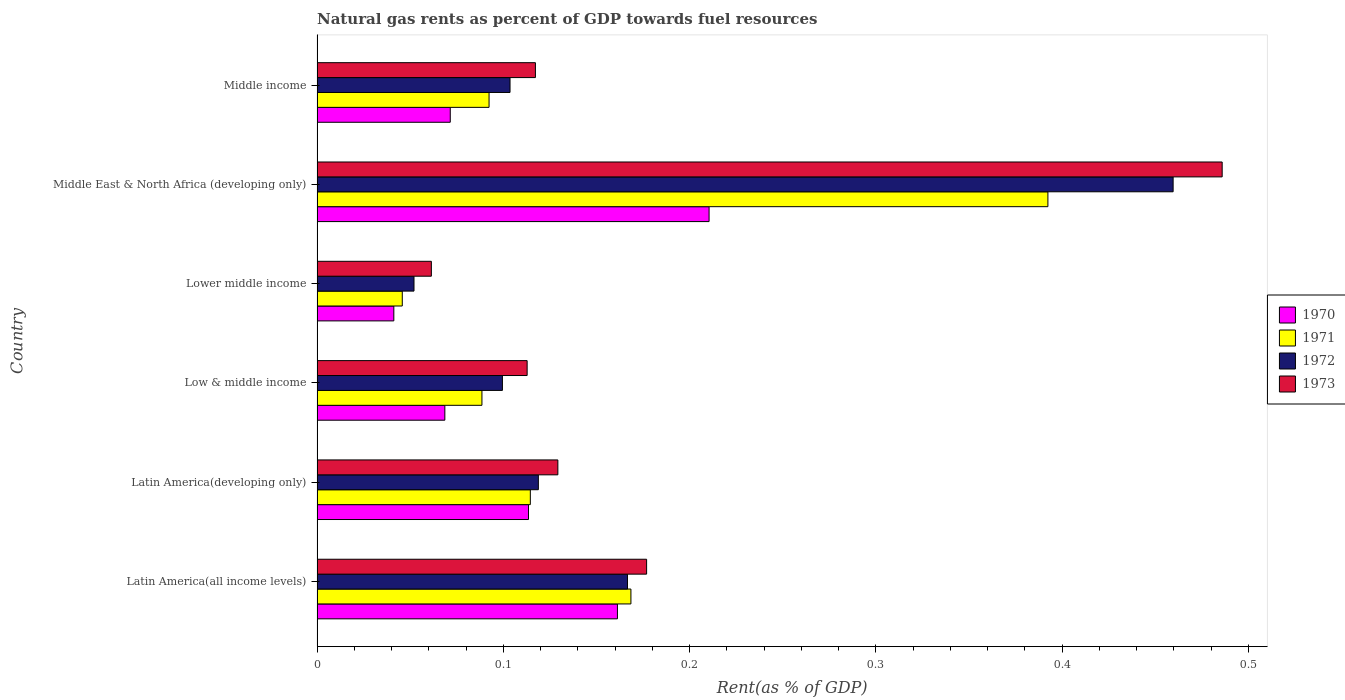Are the number of bars per tick equal to the number of legend labels?
Your answer should be very brief. Yes. How many bars are there on the 2nd tick from the bottom?
Give a very brief answer. 4. What is the label of the 2nd group of bars from the top?
Offer a terse response. Middle East & North Africa (developing only). In how many cases, is the number of bars for a given country not equal to the number of legend labels?
Offer a terse response. 0. What is the matural gas rent in 1972 in Middle East & North Africa (developing only)?
Make the answer very short. 0.46. Across all countries, what is the maximum matural gas rent in 1971?
Offer a terse response. 0.39. Across all countries, what is the minimum matural gas rent in 1973?
Ensure brevity in your answer.  0.06. In which country was the matural gas rent in 1973 maximum?
Provide a short and direct response. Middle East & North Africa (developing only). In which country was the matural gas rent in 1972 minimum?
Your answer should be very brief. Lower middle income. What is the total matural gas rent in 1971 in the graph?
Make the answer very short. 0.9. What is the difference between the matural gas rent in 1972 in Latin America(all income levels) and that in Middle East & North Africa (developing only)?
Make the answer very short. -0.29. What is the difference between the matural gas rent in 1971 in Latin America(developing only) and the matural gas rent in 1970 in Lower middle income?
Your response must be concise. 0.07. What is the average matural gas rent in 1970 per country?
Offer a terse response. 0.11. What is the difference between the matural gas rent in 1972 and matural gas rent in 1970 in Middle East & North Africa (developing only)?
Ensure brevity in your answer.  0.25. What is the ratio of the matural gas rent in 1970 in Latin America(all income levels) to that in Lower middle income?
Ensure brevity in your answer.  3.91. Is the matural gas rent in 1971 in Latin America(developing only) less than that in Middle income?
Provide a succinct answer. No. What is the difference between the highest and the second highest matural gas rent in 1972?
Keep it short and to the point. 0.29. What is the difference between the highest and the lowest matural gas rent in 1970?
Offer a very short reply. 0.17. In how many countries, is the matural gas rent in 1970 greater than the average matural gas rent in 1970 taken over all countries?
Your response must be concise. 3. Is it the case that in every country, the sum of the matural gas rent in 1972 and matural gas rent in 1970 is greater than the sum of matural gas rent in 1971 and matural gas rent in 1973?
Give a very brief answer. No. What does the 4th bar from the top in Low & middle income represents?
Offer a terse response. 1970. What does the 3rd bar from the bottom in Lower middle income represents?
Offer a terse response. 1972. How many bars are there?
Your response must be concise. 24. Are all the bars in the graph horizontal?
Offer a very short reply. Yes. How many countries are there in the graph?
Make the answer very short. 6. How are the legend labels stacked?
Ensure brevity in your answer.  Vertical. What is the title of the graph?
Provide a short and direct response. Natural gas rents as percent of GDP towards fuel resources. Does "1989" appear as one of the legend labels in the graph?
Give a very brief answer. No. What is the label or title of the X-axis?
Provide a short and direct response. Rent(as % of GDP). What is the Rent(as % of GDP) of 1970 in Latin America(all income levels)?
Your answer should be very brief. 0.16. What is the Rent(as % of GDP) of 1971 in Latin America(all income levels)?
Offer a terse response. 0.17. What is the Rent(as % of GDP) of 1972 in Latin America(all income levels)?
Make the answer very short. 0.17. What is the Rent(as % of GDP) in 1973 in Latin America(all income levels)?
Your answer should be compact. 0.18. What is the Rent(as % of GDP) of 1970 in Latin America(developing only)?
Offer a terse response. 0.11. What is the Rent(as % of GDP) in 1971 in Latin America(developing only)?
Make the answer very short. 0.11. What is the Rent(as % of GDP) of 1972 in Latin America(developing only)?
Keep it short and to the point. 0.12. What is the Rent(as % of GDP) of 1973 in Latin America(developing only)?
Provide a succinct answer. 0.13. What is the Rent(as % of GDP) in 1970 in Low & middle income?
Your answer should be very brief. 0.07. What is the Rent(as % of GDP) in 1971 in Low & middle income?
Provide a short and direct response. 0.09. What is the Rent(as % of GDP) in 1972 in Low & middle income?
Your answer should be very brief. 0.1. What is the Rent(as % of GDP) of 1973 in Low & middle income?
Ensure brevity in your answer.  0.11. What is the Rent(as % of GDP) in 1970 in Lower middle income?
Ensure brevity in your answer.  0.04. What is the Rent(as % of GDP) of 1971 in Lower middle income?
Offer a very short reply. 0.05. What is the Rent(as % of GDP) in 1972 in Lower middle income?
Provide a succinct answer. 0.05. What is the Rent(as % of GDP) of 1973 in Lower middle income?
Give a very brief answer. 0.06. What is the Rent(as % of GDP) in 1970 in Middle East & North Africa (developing only)?
Make the answer very short. 0.21. What is the Rent(as % of GDP) in 1971 in Middle East & North Africa (developing only)?
Offer a terse response. 0.39. What is the Rent(as % of GDP) of 1972 in Middle East & North Africa (developing only)?
Your response must be concise. 0.46. What is the Rent(as % of GDP) of 1973 in Middle East & North Africa (developing only)?
Keep it short and to the point. 0.49. What is the Rent(as % of GDP) in 1970 in Middle income?
Give a very brief answer. 0.07. What is the Rent(as % of GDP) in 1971 in Middle income?
Your answer should be compact. 0.09. What is the Rent(as % of GDP) in 1972 in Middle income?
Your answer should be compact. 0.1. What is the Rent(as % of GDP) of 1973 in Middle income?
Ensure brevity in your answer.  0.12. Across all countries, what is the maximum Rent(as % of GDP) in 1970?
Make the answer very short. 0.21. Across all countries, what is the maximum Rent(as % of GDP) of 1971?
Your answer should be very brief. 0.39. Across all countries, what is the maximum Rent(as % of GDP) in 1972?
Provide a succinct answer. 0.46. Across all countries, what is the maximum Rent(as % of GDP) of 1973?
Your answer should be very brief. 0.49. Across all countries, what is the minimum Rent(as % of GDP) of 1970?
Offer a very short reply. 0.04. Across all countries, what is the minimum Rent(as % of GDP) of 1971?
Keep it short and to the point. 0.05. Across all countries, what is the minimum Rent(as % of GDP) of 1972?
Provide a succinct answer. 0.05. Across all countries, what is the minimum Rent(as % of GDP) of 1973?
Your answer should be compact. 0.06. What is the total Rent(as % of GDP) of 1970 in the graph?
Your answer should be very brief. 0.67. What is the total Rent(as % of GDP) of 1971 in the graph?
Your answer should be very brief. 0.9. What is the total Rent(as % of GDP) in 1972 in the graph?
Your answer should be compact. 1. What is the total Rent(as % of GDP) in 1973 in the graph?
Make the answer very short. 1.08. What is the difference between the Rent(as % of GDP) of 1970 in Latin America(all income levels) and that in Latin America(developing only)?
Offer a very short reply. 0.05. What is the difference between the Rent(as % of GDP) of 1971 in Latin America(all income levels) and that in Latin America(developing only)?
Provide a short and direct response. 0.05. What is the difference between the Rent(as % of GDP) in 1972 in Latin America(all income levels) and that in Latin America(developing only)?
Offer a terse response. 0.05. What is the difference between the Rent(as % of GDP) in 1973 in Latin America(all income levels) and that in Latin America(developing only)?
Your response must be concise. 0.05. What is the difference between the Rent(as % of GDP) in 1970 in Latin America(all income levels) and that in Low & middle income?
Offer a terse response. 0.09. What is the difference between the Rent(as % of GDP) of 1972 in Latin America(all income levels) and that in Low & middle income?
Offer a very short reply. 0.07. What is the difference between the Rent(as % of GDP) in 1973 in Latin America(all income levels) and that in Low & middle income?
Give a very brief answer. 0.06. What is the difference between the Rent(as % of GDP) of 1970 in Latin America(all income levels) and that in Lower middle income?
Your answer should be compact. 0.12. What is the difference between the Rent(as % of GDP) in 1971 in Latin America(all income levels) and that in Lower middle income?
Give a very brief answer. 0.12. What is the difference between the Rent(as % of GDP) of 1972 in Latin America(all income levels) and that in Lower middle income?
Offer a very short reply. 0.11. What is the difference between the Rent(as % of GDP) in 1973 in Latin America(all income levels) and that in Lower middle income?
Give a very brief answer. 0.12. What is the difference between the Rent(as % of GDP) in 1970 in Latin America(all income levels) and that in Middle East & North Africa (developing only)?
Ensure brevity in your answer.  -0.05. What is the difference between the Rent(as % of GDP) in 1971 in Latin America(all income levels) and that in Middle East & North Africa (developing only)?
Give a very brief answer. -0.22. What is the difference between the Rent(as % of GDP) in 1972 in Latin America(all income levels) and that in Middle East & North Africa (developing only)?
Your answer should be compact. -0.29. What is the difference between the Rent(as % of GDP) of 1973 in Latin America(all income levels) and that in Middle East & North Africa (developing only)?
Make the answer very short. -0.31. What is the difference between the Rent(as % of GDP) of 1970 in Latin America(all income levels) and that in Middle income?
Your answer should be compact. 0.09. What is the difference between the Rent(as % of GDP) in 1971 in Latin America(all income levels) and that in Middle income?
Your answer should be very brief. 0.08. What is the difference between the Rent(as % of GDP) in 1972 in Latin America(all income levels) and that in Middle income?
Your answer should be very brief. 0.06. What is the difference between the Rent(as % of GDP) of 1973 in Latin America(all income levels) and that in Middle income?
Your answer should be compact. 0.06. What is the difference between the Rent(as % of GDP) of 1970 in Latin America(developing only) and that in Low & middle income?
Give a very brief answer. 0.04. What is the difference between the Rent(as % of GDP) of 1971 in Latin America(developing only) and that in Low & middle income?
Offer a terse response. 0.03. What is the difference between the Rent(as % of GDP) of 1972 in Latin America(developing only) and that in Low & middle income?
Provide a succinct answer. 0.02. What is the difference between the Rent(as % of GDP) in 1973 in Latin America(developing only) and that in Low & middle income?
Make the answer very short. 0.02. What is the difference between the Rent(as % of GDP) in 1970 in Latin America(developing only) and that in Lower middle income?
Provide a short and direct response. 0.07. What is the difference between the Rent(as % of GDP) in 1971 in Latin America(developing only) and that in Lower middle income?
Provide a succinct answer. 0.07. What is the difference between the Rent(as % of GDP) in 1972 in Latin America(developing only) and that in Lower middle income?
Provide a short and direct response. 0.07. What is the difference between the Rent(as % of GDP) in 1973 in Latin America(developing only) and that in Lower middle income?
Your answer should be compact. 0.07. What is the difference between the Rent(as % of GDP) of 1970 in Latin America(developing only) and that in Middle East & North Africa (developing only)?
Keep it short and to the point. -0.1. What is the difference between the Rent(as % of GDP) in 1971 in Latin America(developing only) and that in Middle East & North Africa (developing only)?
Your answer should be very brief. -0.28. What is the difference between the Rent(as % of GDP) of 1972 in Latin America(developing only) and that in Middle East & North Africa (developing only)?
Ensure brevity in your answer.  -0.34. What is the difference between the Rent(as % of GDP) in 1973 in Latin America(developing only) and that in Middle East & North Africa (developing only)?
Your answer should be compact. -0.36. What is the difference between the Rent(as % of GDP) in 1970 in Latin America(developing only) and that in Middle income?
Keep it short and to the point. 0.04. What is the difference between the Rent(as % of GDP) in 1971 in Latin America(developing only) and that in Middle income?
Your response must be concise. 0.02. What is the difference between the Rent(as % of GDP) of 1972 in Latin America(developing only) and that in Middle income?
Make the answer very short. 0.02. What is the difference between the Rent(as % of GDP) of 1973 in Latin America(developing only) and that in Middle income?
Provide a short and direct response. 0.01. What is the difference between the Rent(as % of GDP) of 1970 in Low & middle income and that in Lower middle income?
Make the answer very short. 0.03. What is the difference between the Rent(as % of GDP) of 1971 in Low & middle income and that in Lower middle income?
Provide a short and direct response. 0.04. What is the difference between the Rent(as % of GDP) of 1972 in Low & middle income and that in Lower middle income?
Your answer should be compact. 0.05. What is the difference between the Rent(as % of GDP) of 1973 in Low & middle income and that in Lower middle income?
Provide a short and direct response. 0.05. What is the difference between the Rent(as % of GDP) of 1970 in Low & middle income and that in Middle East & North Africa (developing only)?
Provide a succinct answer. -0.14. What is the difference between the Rent(as % of GDP) of 1971 in Low & middle income and that in Middle East & North Africa (developing only)?
Your answer should be very brief. -0.3. What is the difference between the Rent(as % of GDP) of 1972 in Low & middle income and that in Middle East & North Africa (developing only)?
Your answer should be compact. -0.36. What is the difference between the Rent(as % of GDP) in 1973 in Low & middle income and that in Middle East & North Africa (developing only)?
Your answer should be very brief. -0.37. What is the difference between the Rent(as % of GDP) of 1970 in Low & middle income and that in Middle income?
Provide a short and direct response. -0. What is the difference between the Rent(as % of GDP) in 1971 in Low & middle income and that in Middle income?
Your answer should be very brief. -0. What is the difference between the Rent(as % of GDP) of 1972 in Low & middle income and that in Middle income?
Your answer should be compact. -0. What is the difference between the Rent(as % of GDP) in 1973 in Low & middle income and that in Middle income?
Make the answer very short. -0. What is the difference between the Rent(as % of GDP) of 1970 in Lower middle income and that in Middle East & North Africa (developing only)?
Provide a short and direct response. -0.17. What is the difference between the Rent(as % of GDP) of 1971 in Lower middle income and that in Middle East & North Africa (developing only)?
Keep it short and to the point. -0.35. What is the difference between the Rent(as % of GDP) in 1972 in Lower middle income and that in Middle East & North Africa (developing only)?
Provide a short and direct response. -0.41. What is the difference between the Rent(as % of GDP) of 1973 in Lower middle income and that in Middle East & North Africa (developing only)?
Give a very brief answer. -0.42. What is the difference between the Rent(as % of GDP) of 1970 in Lower middle income and that in Middle income?
Make the answer very short. -0.03. What is the difference between the Rent(as % of GDP) of 1971 in Lower middle income and that in Middle income?
Your answer should be very brief. -0.05. What is the difference between the Rent(as % of GDP) in 1972 in Lower middle income and that in Middle income?
Your answer should be very brief. -0.05. What is the difference between the Rent(as % of GDP) of 1973 in Lower middle income and that in Middle income?
Offer a terse response. -0.06. What is the difference between the Rent(as % of GDP) in 1970 in Middle East & North Africa (developing only) and that in Middle income?
Provide a short and direct response. 0.14. What is the difference between the Rent(as % of GDP) in 1972 in Middle East & North Africa (developing only) and that in Middle income?
Provide a short and direct response. 0.36. What is the difference between the Rent(as % of GDP) in 1973 in Middle East & North Africa (developing only) and that in Middle income?
Make the answer very short. 0.37. What is the difference between the Rent(as % of GDP) in 1970 in Latin America(all income levels) and the Rent(as % of GDP) in 1971 in Latin America(developing only)?
Provide a succinct answer. 0.05. What is the difference between the Rent(as % of GDP) in 1970 in Latin America(all income levels) and the Rent(as % of GDP) in 1972 in Latin America(developing only)?
Your response must be concise. 0.04. What is the difference between the Rent(as % of GDP) in 1970 in Latin America(all income levels) and the Rent(as % of GDP) in 1973 in Latin America(developing only)?
Offer a terse response. 0.03. What is the difference between the Rent(as % of GDP) in 1971 in Latin America(all income levels) and the Rent(as % of GDP) in 1972 in Latin America(developing only)?
Provide a short and direct response. 0.05. What is the difference between the Rent(as % of GDP) in 1971 in Latin America(all income levels) and the Rent(as % of GDP) in 1973 in Latin America(developing only)?
Offer a very short reply. 0.04. What is the difference between the Rent(as % of GDP) of 1972 in Latin America(all income levels) and the Rent(as % of GDP) of 1973 in Latin America(developing only)?
Provide a short and direct response. 0.04. What is the difference between the Rent(as % of GDP) of 1970 in Latin America(all income levels) and the Rent(as % of GDP) of 1971 in Low & middle income?
Provide a succinct answer. 0.07. What is the difference between the Rent(as % of GDP) of 1970 in Latin America(all income levels) and the Rent(as % of GDP) of 1972 in Low & middle income?
Keep it short and to the point. 0.06. What is the difference between the Rent(as % of GDP) of 1970 in Latin America(all income levels) and the Rent(as % of GDP) of 1973 in Low & middle income?
Your answer should be very brief. 0.05. What is the difference between the Rent(as % of GDP) of 1971 in Latin America(all income levels) and the Rent(as % of GDP) of 1972 in Low & middle income?
Provide a succinct answer. 0.07. What is the difference between the Rent(as % of GDP) in 1971 in Latin America(all income levels) and the Rent(as % of GDP) in 1973 in Low & middle income?
Your answer should be compact. 0.06. What is the difference between the Rent(as % of GDP) in 1972 in Latin America(all income levels) and the Rent(as % of GDP) in 1973 in Low & middle income?
Your answer should be very brief. 0.05. What is the difference between the Rent(as % of GDP) in 1970 in Latin America(all income levels) and the Rent(as % of GDP) in 1971 in Lower middle income?
Your answer should be compact. 0.12. What is the difference between the Rent(as % of GDP) in 1970 in Latin America(all income levels) and the Rent(as % of GDP) in 1972 in Lower middle income?
Your response must be concise. 0.11. What is the difference between the Rent(as % of GDP) in 1970 in Latin America(all income levels) and the Rent(as % of GDP) in 1973 in Lower middle income?
Your response must be concise. 0.1. What is the difference between the Rent(as % of GDP) in 1971 in Latin America(all income levels) and the Rent(as % of GDP) in 1972 in Lower middle income?
Make the answer very short. 0.12. What is the difference between the Rent(as % of GDP) in 1971 in Latin America(all income levels) and the Rent(as % of GDP) in 1973 in Lower middle income?
Provide a succinct answer. 0.11. What is the difference between the Rent(as % of GDP) in 1972 in Latin America(all income levels) and the Rent(as % of GDP) in 1973 in Lower middle income?
Offer a terse response. 0.11. What is the difference between the Rent(as % of GDP) in 1970 in Latin America(all income levels) and the Rent(as % of GDP) in 1971 in Middle East & North Africa (developing only)?
Your answer should be compact. -0.23. What is the difference between the Rent(as % of GDP) of 1970 in Latin America(all income levels) and the Rent(as % of GDP) of 1972 in Middle East & North Africa (developing only)?
Your answer should be compact. -0.3. What is the difference between the Rent(as % of GDP) in 1970 in Latin America(all income levels) and the Rent(as % of GDP) in 1973 in Middle East & North Africa (developing only)?
Your answer should be very brief. -0.32. What is the difference between the Rent(as % of GDP) of 1971 in Latin America(all income levels) and the Rent(as % of GDP) of 1972 in Middle East & North Africa (developing only)?
Ensure brevity in your answer.  -0.29. What is the difference between the Rent(as % of GDP) in 1971 in Latin America(all income levels) and the Rent(as % of GDP) in 1973 in Middle East & North Africa (developing only)?
Make the answer very short. -0.32. What is the difference between the Rent(as % of GDP) of 1972 in Latin America(all income levels) and the Rent(as % of GDP) of 1973 in Middle East & North Africa (developing only)?
Keep it short and to the point. -0.32. What is the difference between the Rent(as % of GDP) of 1970 in Latin America(all income levels) and the Rent(as % of GDP) of 1971 in Middle income?
Offer a terse response. 0.07. What is the difference between the Rent(as % of GDP) of 1970 in Latin America(all income levels) and the Rent(as % of GDP) of 1972 in Middle income?
Provide a succinct answer. 0.06. What is the difference between the Rent(as % of GDP) in 1970 in Latin America(all income levels) and the Rent(as % of GDP) in 1973 in Middle income?
Your answer should be compact. 0.04. What is the difference between the Rent(as % of GDP) in 1971 in Latin America(all income levels) and the Rent(as % of GDP) in 1972 in Middle income?
Your answer should be very brief. 0.06. What is the difference between the Rent(as % of GDP) in 1971 in Latin America(all income levels) and the Rent(as % of GDP) in 1973 in Middle income?
Make the answer very short. 0.05. What is the difference between the Rent(as % of GDP) of 1972 in Latin America(all income levels) and the Rent(as % of GDP) of 1973 in Middle income?
Provide a succinct answer. 0.05. What is the difference between the Rent(as % of GDP) of 1970 in Latin America(developing only) and the Rent(as % of GDP) of 1971 in Low & middle income?
Provide a short and direct response. 0.03. What is the difference between the Rent(as % of GDP) of 1970 in Latin America(developing only) and the Rent(as % of GDP) of 1972 in Low & middle income?
Make the answer very short. 0.01. What is the difference between the Rent(as % of GDP) of 1970 in Latin America(developing only) and the Rent(as % of GDP) of 1973 in Low & middle income?
Provide a succinct answer. 0. What is the difference between the Rent(as % of GDP) of 1971 in Latin America(developing only) and the Rent(as % of GDP) of 1972 in Low & middle income?
Your answer should be very brief. 0.01. What is the difference between the Rent(as % of GDP) of 1971 in Latin America(developing only) and the Rent(as % of GDP) of 1973 in Low & middle income?
Ensure brevity in your answer.  0. What is the difference between the Rent(as % of GDP) in 1972 in Latin America(developing only) and the Rent(as % of GDP) in 1973 in Low & middle income?
Your response must be concise. 0.01. What is the difference between the Rent(as % of GDP) of 1970 in Latin America(developing only) and the Rent(as % of GDP) of 1971 in Lower middle income?
Provide a short and direct response. 0.07. What is the difference between the Rent(as % of GDP) in 1970 in Latin America(developing only) and the Rent(as % of GDP) in 1972 in Lower middle income?
Provide a short and direct response. 0.06. What is the difference between the Rent(as % of GDP) of 1970 in Latin America(developing only) and the Rent(as % of GDP) of 1973 in Lower middle income?
Provide a short and direct response. 0.05. What is the difference between the Rent(as % of GDP) in 1971 in Latin America(developing only) and the Rent(as % of GDP) in 1972 in Lower middle income?
Provide a short and direct response. 0.06. What is the difference between the Rent(as % of GDP) of 1971 in Latin America(developing only) and the Rent(as % of GDP) of 1973 in Lower middle income?
Offer a very short reply. 0.05. What is the difference between the Rent(as % of GDP) of 1972 in Latin America(developing only) and the Rent(as % of GDP) of 1973 in Lower middle income?
Make the answer very short. 0.06. What is the difference between the Rent(as % of GDP) in 1970 in Latin America(developing only) and the Rent(as % of GDP) in 1971 in Middle East & North Africa (developing only)?
Your answer should be compact. -0.28. What is the difference between the Rent(as % of GDP) in 1970 in Latin America(developing only) and the Rent(as % of GDP) in 1972 in Middle East & North Africa (developing only)?
Offer a terse response. -0.35. What is the difference between the Rent(as % of GDP) in 1970 in Latin America(developing only) and the Rent(as % of GDP) in 1973 in Middle East & North Africa (developing only)?
Provide a short and direct response. -0.37. What is the difference between the Rent(as % of GDP) in 1971 in Latin America(developing only) and the Rent(as % of GDP) in 1972 in Middle East & North Africa (developing only)?
Your response must be concise. -0.35. What is the difference between the Rent(as % of GDP) in 1971 in Latin America(developing only) and the Rent(as % of GDP) in 1973 in Middle East & North Africa (developing only)?
Keep it short and to the point. -0.37. What is the difference between the Rent(as % of GDP) in 1972 in Latin America(developing only) and the Rent(as % of GDP) in 1973 in Middle East & North Africa (developing only)?
Keep it short and to the point. -0.37. What is the difference between the Rent(as % of GDP) in 1970 in Latin America(developing only) and the Rent(as % of GDP) in 1971 in Middle income?
Make the answer very short. 0.02. What is the difference between the Rent(as % of GDP) in 1970 in Latin America(developing only) and the Rent(as % of GDP) in 1972 in Middle income?
Your answer should be compact. 0.01. What is the difference between the Rent(as % of GDP) in 1970 in Latin America(developing only) and the Rent(as % of GDP) in 1973 in Middle income?
Make the answer very short. -0. What is the difference between the Rent(as % of GDP) of 1971 in Latin America(developing only) and the Rent(as % of GDP) of 1972 in Middle income?
Provide a succinct answer. 0.01. What is the difference between the Rent(as % of GDP) of 1971 in Latin America(developing only) and the Rent(as % of GDP) of 1973 in Middle income?
Offer a terse response. -0. What is the difference between the Rent(as % of GDP) in 1972 in Latin America(developing only) and the Rent(as % of GDP) in 1973 in Middle income?
Make the answer very short. 0. What is the difference between the Rent(as % of GDP) in 1970 in Low & middle income and the Rent(as % of GDP) in 1971 in Lower middle income?
Keep it short and to the point. 0.02. What is the difference between the Rent(as % of GDP) in 1970 in Low & middle income and the Rent(as % of GDP) in 1972 in Lower middle income?
Your answer should be compact. 0.02. What is the difference between the Rent(as % of GDP) in 1970 in Low & middle income and the Rent(as % of GDP) in 1973 in Lower middle income?
Give a very brief answer. 0.01. What is the difference between the Rent(as % of GDP) of 1971 in Low & middle income and the Rent(as % of GDP) of 1972 in Lower middle income?
Offer a very short reply. 0.04. What is the difference between the Rent(as % of GDP) in 1971 in Low & middle income and the Rent(as % of GDP) in 1973 in Lower middle income?
Your answer should be compact. 0.03. What is the difference between the Rent(as % of GDP) of 1972 in Low & middle income and the Rent(as % of GDP) of 1973 in Lower middle income?
Provide a short and direct response. 0.04. What is the difference between the Rent(as % of GDP) in 1970 in Low & middle income and the Rent(as % of GDP) in 1971 in Middle East & North Africa (developing only)?
Make the answer very short. -0.32. What is the difference between the Rent(as % of GDP) in 1970 in Low & middle income and the Rent(as % of GDP) in 1972 in Middle East & North Africa (developing only)?
Ensure brevity in your answer.  -0.39. What is the difference between the Rent(as % of GDP) in 1970 in Low & middle income and the Rent(as % of GDP) in 1973 in Middle East & North Africa (developing only)?
Offer a very short reply. -0.42. What is the difference between the Rent(as % of GDP) in 1971 in Low & middle income and the Rent(as % of GDP) in 1972 in Middle East & North Africa (developing only)?
Give a very brief answer. -0.37. What is the difference between the Rent(as % of GDP) of 1971 in Low & middle income and the Rent(as % of GDP) of 1973 in Middle East & North Africa (developing only)?
Provide a succinct answer. -0.4. What is the difference between the Rent(as % of GDP) of 1972 in Low & middle income and the Rent(as % of GDP) of 1973 in Middle East & North Africa (developing only)?
Offer a terse response. -0.39. What is the difference between the Rent(as % of GDP) in 1970 in Low & middle income and the Rent(as % of GDP) in 1971 in Middle income?
Offer a terse response. -0.02. What is the difference between the Rent(as % of GDP) in 1970 in Low & middle income and the Rent(as % of GDP) in 1972 in Middle income?
Make the answer very short. -0.04. What is the difference between the Rent(as % of GDP) in 1970 in Low & middle income and the Rent(as % of GDP) in 1973 in Middle income?
Make the answer very short. -0.05. What is the difference between the Rent(as % of GDP) of 1971 in Low & middle income and the Rent(as % of GDP) of 1972 in Middle income?
Your response must be concise. -0.02. What is the difference between the Rent(as % of GDP) of 1971 in Low & middle income and the Rent(as % of GDP) of 1973 in Middle income?
Give a very brief answer. -0.03. What is the difference between the Rent(as % of GDP) in 1972 in Low & middle income and the Rent(as % of GDP) in 1973 in Middle income?
Keep it short and to the point. -0.02. What is the difference between the Rent(as % of GDP) of 1970 in Lower middle income and the Rent(as % of GDP) of 1971 in Middle East & North Africa (developing only)?
Your answer should be very brief. -0.35. What is the difference between the Rent(as % of GDP) in 1970 in Lower middle income and the Rent(as % of GDP) in 1972 in Middle East & North Africa (developing only)?
Give a very brief answer. -0.42. What is the difference between the Rent(as % of GDP) in 1970 in Lower middle income and the Rent(as % of GDP) in 1973 in Middle East & North Africa (developing only)?
Offer a terse response. -0.44. What is the difference between the Rent(as % of GDP) in 1971 in Lower middle income and the Rent(as % of GDP) in 1972 in Middle East & North Africa (developing only)?
Provide a short and direct response. -0.41. What is the difference between the Rent(as % of GDP) in 1971 in Lower middle income and the Rent(as % of GDP) in 1973 in Middle East & North Africa (developing only)?
Provide a short and direct response. -0.44. What is the difference between the Rent(as % of GDP) of 1972 in Lower middle income and the Rent(as % of GDP) of 1973 in Middle East & North Africa (developing only)?
Your answer should be very brief. -0.43. What is the difference between the Rent(as % of GDP) in 1970 in Lower middle income and the Rent(as % of GDP) in 1971 in Middle income?
Offer a terse response. -0.05. What is the difference between the Rent(as % of GDP) of 1970 in Lower middle income and the Rent(as % of GDP) of 1972 in Middle income?
Make the answer very short. -0.06. What is the difference between the Rent(as % of GDP) of 1970 in Lower middle income and the Rent(as % of GDP) of 1973 in Middle income?
Ensure brevity in your answer.  -0.08. What is the difference between the Rent(as % of GDP) of 1971 in Lower middle income and the Rent(as % of GDP) of 1972 in Middle income?
Your response must be concise. -0.06. What is the difference between the Rent(as % of GDP) of 1971 in Lower middle income and the Rent(as % of GDP) of 1973 in Middle income?
Keep it short and to the point. -0.07. What is the difference between the Rent(as % of GDP) of 1972 in Lower middle income and the Rent(as % of GDP) of 1973 in Middle income?
Give a very brief answer. -0.07. What is the difference between the Rent(as % of GDP) of 1970 in Middle East & North Africa (developing only) and the Rent(as % of GDP) of 1971 in Middle income?
Provide a short and direct response. 0.12. What is the difference between the Rent(as % of GDP) of 1970 in Middle East & North Africa (developing only) and the Rent(as % of GDP) of 1972 in Middle income?
Your answer should be very brief. 0.11. What is the difference between the Rent(as % of GDP) of 1970 in Middle East & North Africa (developing only) and the Rent(as % of GDP) of 1973 in Middle income?
Your answer should be compact. 0.09. What is the difference between the Rent(as % of GDP) of 1971 in Middle East & North Africa (developing only) and the Rent(as % of GDP) of 1972 in Middle income?
Provide a short and direct response. 0.29. What is the difference between the Rent(as % of GDP) of 1971 in Middle East & North Africa (developing only) and the Rent(as % of GDP) of 1973 in Middle income?
Your answer should be compact. 0.28. What is the difference between the Rent(as % of GDP) of 1972 in Middle East & North Africa (developing only) and the Rent(as % of GDP) of 1973 in Middle income?
Give a very brief answer. 0.34. What is the average Rent(as % of GDP) of 1971 per country?
Give a very brief answer. 0.15. What is the average Rent(as % of GDP) in 1973 per country?
Ensure brevity in your answer.  0.18. What is the difference between the Rent(as % of GDP) of 1970 and Rent(as % of GDP) of 1971 in Latin America(all income levels)?
Your answer should be very brief. -0.01. What is the difference between the Rent(as % of GDP) in 1970 and Rent(as % of GDP) in 1972 in Latin America(all income levels)?
Your answer should be very brief. -0.01. What is the difference between the Rent(as % of GDP) of 1970 and Rent(as % of GDP) of 1973 in Latin America(all income levels)?
Keep it short and to the point. -0.02. What is the difference between the Rent(as % of GDP) of 1971 and Rent(as % of GDP) of 1972 in Latin America(all income levels)?
Keep it short and to the point. 0. What is the difference between the Rent(as % of GDP) in 1971 and Rent(as % of GDP) in 1973 in Latin America(all income levels)?
Offer a very short reply. -0.01. What is the difference between the Rent(as % of GDP) of 1972 and Rent(as % of GDP) of 1973 in Latin America(all income levels)?
Provide a succinct answer. -0.01. What is the difference between the Rent(as % of GDP) in 1970 and Rent(as % of GDP) in 1971 in Latin America(developing only)?
Give a very brief answer. -0. What is the difference between the Rent(as % of GDP) in 1970 and Rent(as % of GDP) in 1972 in Latin America(developing only)?
Offer a very short reply. -0.01. What is the difference between the Rent(as % of GDP) of 1970 and Rent(as % of GDP) of 1973 in Latin America(developing only)?
Offer a terse response. -0.02. What is the difference between the Rent(as % of GDP) of 1971 and Rent(as % of GDP) of 1972 in Latin America(developing only)?
Offer a very short reply. -0. What is the difference between the Rent(as % of GDP) of 1971 and Rent(as % of GDP) of 1973 in Latin America(developing only)?
Provide a short and direct response. -0.01. What is the difference between the Rent(as % of GDP) in 1972 and Rent(as % of GDP) in 1973 in Latin America(developing only)?
Offer a terse response. -0.01. What is the difference between the Rent(as % of GDP) of 1970 and Rent(as % of GDP) of 1971 in Low & middle income?
Your answer should be compact. -0.02. What is the difference between the Rent(as % of GDP) in 1970 and Rent(as % of GDP) in 1972 in Low & middle income?
Give a very brief answer. -0.03. What is the difference between the Rent(as % of GDP) in 1970 and Rent(as % of GDP) in 1973 in Low & middle income?
Provide a short and direct response. -0.04. What is the difference between the Rent(as % of GDP) in 1971 and Rent(as % of GDP) in 1972 in Low & middle income?
Your response must be concise. -0.01. What is the difference between the Rent(as % of GDP) of 1971 and Rent(as % of GDP) of 1973 in Low & middle income?
Make the answer very short. -0.02. What is the difference between the Rent(as % of GDP) in 1972 and Rent(as % of GDP) in 1973 in Low & middle income?
Provide a short and direct response. -0.01. What is the difference between the Rent(as % of GDP) of 1970 and Rent(as % of GDP) of 1971 in Lower middle income?
Keep it short and to the point. -0. What is the difference between the Rent(as % of GDP) in 1970 and Rent(as % of GDP) in 1972 in Lower middle income?
Provide a short and direct response. -0.01. What is the difference between the Rent(as % of GDP) in 1970 and Rent(as % of GDP) in 1973 in Lower middle income?
Offer a very short reply. -0.02. What is the difference between the Rent(as % of GDP) in 1971 and Rent(as % of GDP) in 1972 in Lower middle income?
Give a very brief answer. -0.01. What is the difference between the Rent(as % of GDP) in 1971 and Rent(as % of GDP) in 1973 in Lower middle income?
Offer a very short reply. -0.02. What is the difference between the Rent(as % of GDP) in 1972 and Rent(as % of GDP) in 1973 in Lower middle income?
Ensure brevity in your answer.  -0.01. What is the difference between the Rent(as % of GDP) of 1970 and Rent(as % of GDP) of 1971 in Middle East & North Africa (developing only)?
Provide a succinct answer. -0.18. What is the difference between the Rent(as % of GDP) in 1970 and Rent(as % of GDP) in 1972 in Middle East & North Africa (developing only)?
Make the answer very short. -0.25. What is the difference between the Rent(as % of GDP) of 1970 and Rent(as % of GDP) of 1973 in Middle East & North Africa (developing only)?
Your response must be concise. -0.28. What is the difference between the Rent(as % of GDP) in 1971 and Rent(as % of GDP) in 1972 in Middle East & North Africa (developing only)?
Provide a succinct answer. -0.07. What is the difference between the Rent(as % of GDP) of 1971 and Rent(as % of GDP) of 1973 in Middle East & North Africa (developing only)?
Your answer should be compact. -0.09. What is the difference between the Rent(as % of GDP) in 1972 and Rent(as % of GDP) in 1973 in Middle East & North Africa (developing only)?
Provide a short and direct response. -0.03. What is the difference between the Rent(as % of GDP) of 1970 and Rent(as % of GDP) of 1971 in Middle income?
Your response must be concise. -0.02. What is the difference between the Rent(as % of GDP) in 1970 and Rent(as % of GDP) in 1972 in Middle income?
Ensure brevity in your answer.  -0.03. What is the difference between the Rent(as % of GDP) of 1970 and Rent(as % of GDP) of 1973 in Middle income?
Give a very brief answer. -0.05. What is the difference between the Rent(as % of GDP) in 1971 and Rent(as % of GDP) in 1972 in Middle income?
Your answer should be compact. -0.01. What is the difference between the Rent(as % of GDP) of 1971 and Rent(as % of GDP) of 1973 in Middle income?
Offer a terse response. -0.02. What is the difference between the Rent(as % of GDP) of 1972 and Rent(as % of GDP) of 1973 in Middle income?
Ensure brevity in your answer.  -0.01. What is the ratio of the Rent(as % of GDP) of 1970 in Latin America(all income levels) to that in Latin America(developing only)?
Offer a terse response. 1.42. What is the ratio of the Rent(as % of GDP) in 1971 in Latin America(all income levels) to that in Latin America(developing only)?
Ensure brevity in your answer.  1.47. What is the ratio of the Rent(as % of GDP) in 1972 in Latin America(all income levels) to that in Latin America(developing only)?
Your answer should be compact. 1.4. What is the ratio of the Rent(as % of GDP) in 1973 in Latin America(all income levels) to that in Latin America(developing only)?
Your answer should be very brief. 1.37. What is the ratio of the Rent(as % of GDP) in 1970 in Latin America(all income levels) to that in Low & middle income?
Ensure brevity in your answer.  2.35. What is the ratio of the Rent(as % of GDP) in 1971 in Latin America(all income levels) to that in Low & middle income?
Offer a very short reply. 1.9. What is the ratio of the Rent(as % of GDP) of 1972 in Latin America(all income levels) to that in Low & middle income?
Your answer should be compact. 1.67. What is the ratio of the Rent(as % of GDP) of 1973 in Latin America(all income levels) to that in Low & middle income?
Offer a very short reply. 1.57. What is the ratio of the Rent(as % of GDP) of 1970 in Latin America(all income levels) to that in Lower middle income?
Offer a very short reply. 3.91. What is the ratio of the Rent(as % of GDP) of 1971 in Latin America(all income levels) to that in Lower middle income?
Your answer should be compact. 3.68. What is the ratio of the Rent(as % of GDP) in 1972 in Latin America(all income levels) to that in Lower middle income?
Your response must be concise. 3.2. What is the ratio of the Rent(as % of GDP) of 1973 in Latin America(all income levels) to that in Lower middle income?
Give a very brief answer. 2.88. What is the ratio of the Rent(as % of GDP) of 1970 in Latin America(all income levels) to that in Middle East & North Africa (developing only)?
Your answer should be very brief. 0.77. What is the ratio of the Rent(as % of GDP) in 1971 in Latin America(all income levels) to that in Middle East & North Africa (developing only)?
Keep it short and to the point. 0.43. What is the ratio of the Rent(as % of GDP) of 1972 in Latin America(all income levels) to that in Middle East & North Africa (developing only)?
Your answer should be very brief. 0.36. What is the ratio of the Rent(as % of GDP) in 1973 in Latin America(all income levels) to that in Middle East & North Africa (developing only)?
Provide a short and direct response. 0.36. What is the ratio of the Rent(as % of GDP) of 1970 in Latin America(all income levels) to that in Middle income?
Provide a succinct answer. 2.25. What is the ratio of the Rent(as % of GDP) in 1971 in Latin America(all income levels) to that in Middle income?
Your response must be concise. 1.82. What is the ratio of the Rent(as % of GDP) in 1972 in Latin America(all income levels) to that in Middle income?
Keep it short and to the point. 1.61. What is the ratio of the Rent(as % of GDP) of 1973 in Latin America(all income levels) to that in Middle income?
Offer a very short reply. 1.51. What is the ratio of the Rent(as % of GDP) of 1970 in Latin America(developing only) to that in Low & middle income?
Offer a very short reply. 1.65. What is the ratio of the Rent(as % of GDP) in 1971 in Latin America(developing only) to that in Low & middle income?
Offer a very short reply. 1.29. What is the ratio of the Rent(as % of GDP) of 1972 in Latin America(developing only) to that in Low & middle income?
Offer a very short reply. 1.19. What is the ratio of the Rent(as % of GDP) of 1973 in Latin America(developing only) to that in Low & middle income?
Your answer should be very brief. 1.15. What is the ratio of the Rent(as % of GDP) in 1970 in Latin America(developing only) to that in Lower middle income?
Keep it short and to the point. 2.75. What is the ratio of the Rent(as % of GDP) in 1971 in Latin America(developing only) to that in Lower middle income?
Make the answer very short. 2.5. What is the ratio of the Rent(as % of GDP) in 1972 in Latin America(developing only) to that in Lower middle income?
Offer a very short reply. 2.28. What is the ratio of the Rent(as % of GDP) of 1973 in Latin America(developing only) to that in Lower middle income?
Make the answer very short. 2.11. What is the ratio of the Rent(as % of GDP) in 1970 in Latin America(developing only) to that in Middle East & North Africa (developing only)?
Make the answer very short. 0.54. What is the ratio of the Rent(as % of GDP) of 1971 in Latin America(developing only) to that in Middle East & North Africa (developing only)?
Give a very brief answer. 0.29. What is the ratio of the Rent(as % of GDP) in 1972 in Latin America(developing only) to that in Middle East & North Africa (developing only)?
Provide a succinct answer. 0.26. What is the ratio of the Rent(as % of GDP) in 1973 in Latin America(developing only) to that in Middle East & North Africa (developing only)?
Offer a very short reply. 0.27. What is the ratio of the Rent(as % of GDP) of 1970 in Latin America(developing only) to that in Middle income?
Offer a very short reply. 1.59. What is the ratio of the Rent(as % of GDP) of 1971 in Latin America(developing only) to that in Middle income?
Your answer should be very brief. 1.24. What is the ratio of the Rent(as % of GDP) in 1972 in Latin America(developing only) to that in Middle income?
Offer a terse response. 1.15. What is the ratio of the Rent(as % of GDP) in 1973 in Latin America(developing only) to that in Middle income?
Offer a very short reply. 1.1. What is the ratio of the Rent(as % of GDP) in 1970 in Low & middle income to that in Lower middle income?
Keep it short and to the point. 1.66. What is the ratio of the Rent(as % of GDP) in 1971 in Low & middle income to that in Lower middle income?
Give a very brief answer. 1.93. What is the ratio of the Rent(as % of GDP) in 1972 in Low & middle income to that in Lower middle income?
Your answer should be compact. 1.91. What is the ratio of the Rent(as % of GDP) of 1973 in Low & middle income to that in Lower middle income?
Ensure brevity in your answer.  1.84. What is the ratio of the Rent(as % of GDP) of 1970 in Low & middle income to that in Middle East & North Africa (developing only)?
Ensure brevity in your answer.  0.33. What is the ratio of the Rent(as % of GDP) in 1971 in Low & middle income to that in Middle East & North Africa (developing only)?
Keep it short and to the point. 0.23. What is the ratio of the Rent(as % of GDP) of 1972 in Low & middle income to that in Middle East & North Africa (developing only)?
Your answer should be very brief. 0.22. What is the ratio of the Rent(as % of GDP) in 1973 in Low & middle income to that in Middle East & North Africa (developing only)?
Your answer should be compact. 0.23. What is the ratio of the Rent(as % of GDP) of 1970 in Low & middle income to that in Middle income?
Give a very brief answer. 0.96. What is the ratio of the Rent(as % of GDP) of 1971 in Low & middle income to that in Middle income?
Your answer should be compact. 0.96. What is the ratio of the Rent(as % of GDP) in 1972 in Low & middle income to that in Middle income?
Offer a very short reply. 0.96. What is the ratio of the Rent(as % of GDP) in 1973 in Low & middle income to that in Middle income?
Provide a short and direct response. 0.96. What is the ratio of the Rent(as % of GDP) in 1970 in Lower middle income to that in Middle East & North Africa (developing only)?
Your response must be concise. 0.2. What is the ratio of the Rent(as % of GDP) in 1971 in Lower middle income to that in Middle East & North Africa (developing only)?
Provide a short and direct response. 0.12. What is the ratio of the Rent(as % of GDP) of 1972 in Lower middle income to that in Middle East & North Africa (developing only)?
Your answer should be very brief. 0.11. What is the ratio of the Rent(as % of GDP) of 1973 in Lower middle income to that in Middle East & North Africa (developing only)?
Offer a very short reply. 0.13. What is the ratio of the Rent(as % of GDP) in 1970 in Lower middle income to that in Middle income?
Offer a very short reply. 0.58. What is the ratio of the Rent(as % of GDP) in 1971 in Lower middle income to that in Middle income?
Offer a terse response. 0.5. What is the ratio of the Rent(as % of GDP) of 1972 in Lower middle income to that in Middle income?
Offer a very short reply. 0.5. What is the ratio of the Rent(as % of GDP) of 1973 in Lower middle income to that in Middle income?
Give a very brief answer. 0.52. What is the ratio of the Rent(as % of GDP) of 1970 in Middle East & North Africa (developing only) to that in Middle income?
Your answer should be compact. 2.94. What is the ratio of the Rent(as % of GDP) of 1971 in Middle East & North Africa (developing only) to that in Middle income?
Your response must be concise. 4.25. What is the ratio of the Rent(as % of GDP) of 1972 in Middle East & North Africa (developing only) to that in Middle income?
Offer a very short reply. 4.44. What is the ratio of the Rent(as % of GDP) in 1973 in Middle East & North Africa (developing only) to that in Middle income?
Make the answer very short. 4.14. What is the difference between the highest and the second highest Rent(as % of GDP) of 1970?
Make the answer very short. 0.05. What is the difference between the highest and the second highest Rent(as % of GDP) of 1971?
Keep it short and to the point. 0.22. What is the difference between the highest and the second highest Rent(as % of GDP) of 1972?
Your answer should be very brief. 0.29. What is the difference between the highest and the second highest Rent(as % of GDP) in 1973?
Provide a succinct answer. 0.31. What is the difference between the highest and the lowest Rent(as % of GDP) in 1970?
Provide a succinct answer. 0.17. What is the difference between the highest and the lowest Rent(as % of GDP) in 1971?
Provide a short and direct response. 0.35. What is the difference between the highest and the lowest Rent(as % of GDP) of 1972?
Your response must be concise. 0.41. What is the difference between the highest and the lowest Rent(as % of GDP) of 1973?
Offer a very short reply. 0.42. 